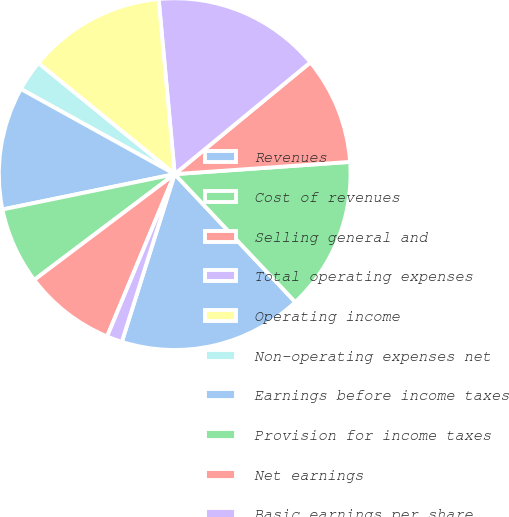Convert chart to OTSL. <chart><loc_0><loc_0><loc_500><loc_500><pie_chart><fcel>Revenues<fcel>Cost of revenues<fcel>Selling general and<fcel>Total operating expenses<fcel>Operating income<fcel>Non-operating expenses net<fcel>Earnings before income taxes<fcel>Provision for income taxes<fcel>Net earnings<fcel>Basic earnings per share<nl><fcel>16.89%<fcel>14.08%<fcel>9.86%<fcel>15.49%<fcel>12.67%<fcel>2.83%<fcel>11.27%<fcel>7.05%<fcel>8.45%<fcel>1.42%<nl></chart> 